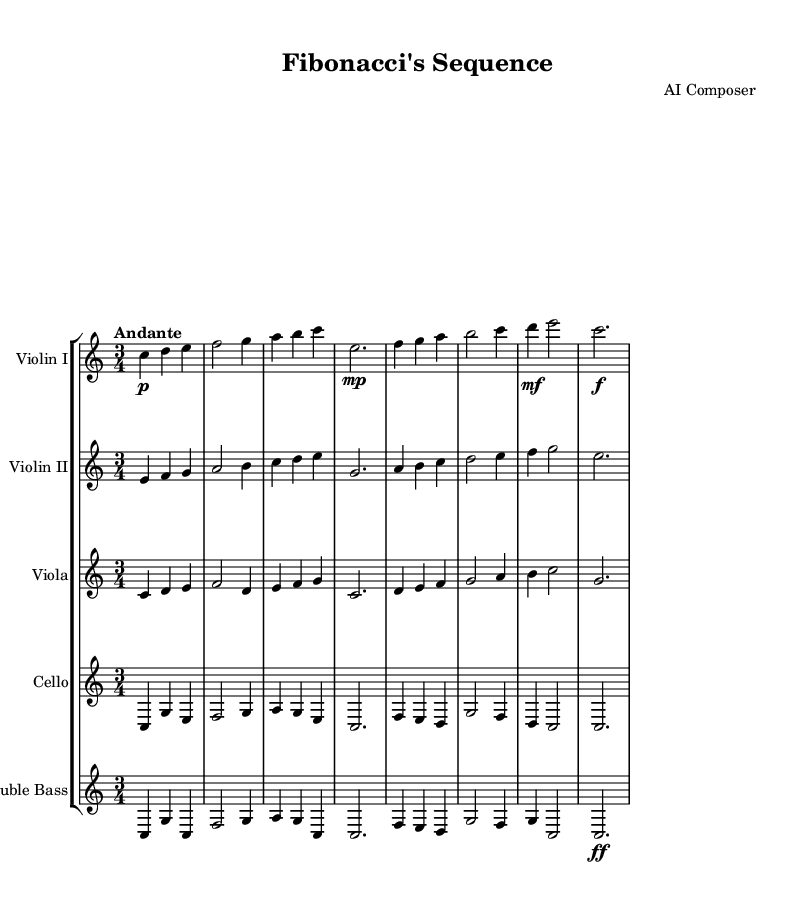What is the key signature of this music? The key signature is indicated at the beginning of the score. In this case, it shows no sharps or flats, which corresponds to C major.
Answer: C major What is the time signature of this piece? The time signature is found near the beginning of the score, and here it is written as 3/4, indicating three beats per measure.
Answer: 3/4 What is the tempo marking for this composition? The tempo marking appears in the score and indicates how fast the piece should be played. In this score, it specifies "Andante", suggesting a moderate tempo.
Answer: Andante How many measures are present in the first violin part? By counting the distinct lines of music in the Violin I staff, one can determine the number of measures. There are a total of eight measures present.
Answer: Eight Which instrument plays the lowest notes in the score? Looking at the instrument range, the Double Bass is notated with the lowest pitches, making it the instrument that plays the lowest notes.
Answer: Double Bass What rhythmic pattern predominates this piece? Analyzing the notes reveals a typical three-beat rhythmic pattern since the time signature is 3/4. This results in a recurring emphasis on the first beat.
Answer: Three-beat Which mathematical sequence inspired this symphonic work? The title of the composition directly references "Fibonacci's Sequence," which is a well-known mathematical concept where each number is the sum of the two preceding ones.
Answer: Fibonacci's Sequence 